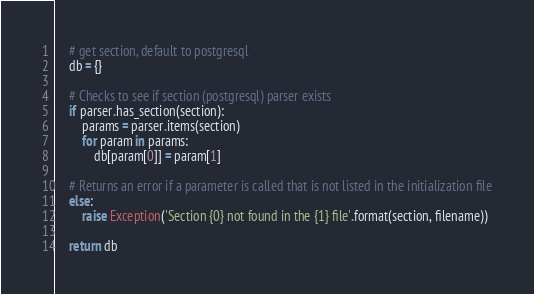Convert code to text. <code><loc_0><loc_0><loc_500><loc_500><_Python_>    # get section, default to postgresql
    db = {}
    
    # Checks to see if section (postgresql) parser exists
    if parser.has_section(section):
        params = parser.items(section)
        for param in params:
            db[param[0]] = param[1]
         
    # Returns an error if a parameter is called that is not listed in the initialization file
    else:
        raise Exception('Section {0} not found in the {1} file'.format(section, filename))
 
    return db</code> 